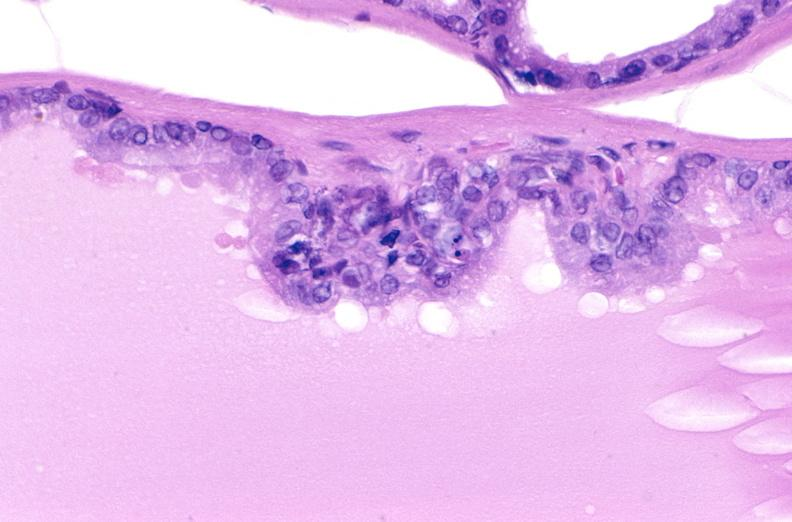does this image show apoptosis in prostate after orchiectomy?
Answer the question using a single word or phrase. Yes 